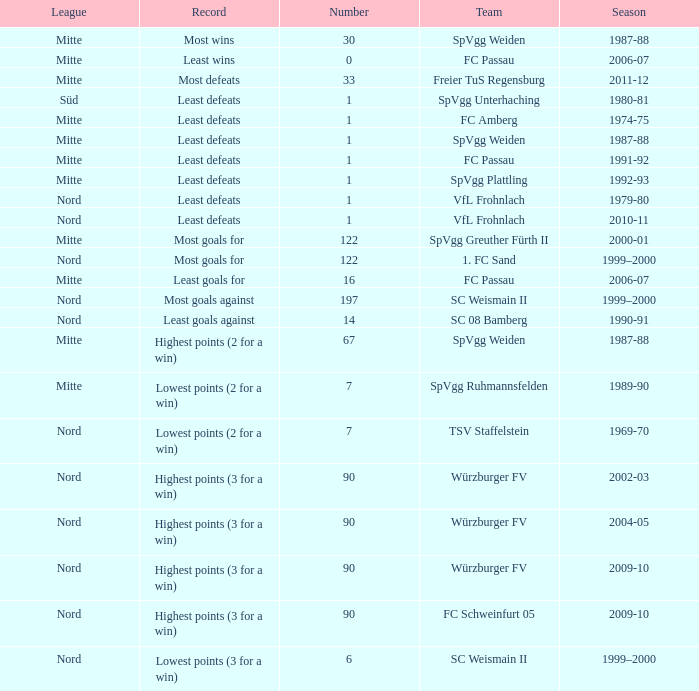Could you help me parse every detail presented in this table? {'header': ['League', 'Record', 'Number', 'Team', 'Season'], 'rows': [['Mitte', 'Most wins', '30', 'SpVgg Weiden', '1987-88'], ['Mitte', 'Least wins', '0', 'FC Passau', '2006-07'], ['Mitte', 'Most defeats', '33', 'Freier TuS Regensburg', '2011-12'], ['Süd', 'Least defeats', '1', 'SpVgg Unterhaching', '1980-81'], ['Mitte', 'Least defeats', '1', 'FC Amberg', '1974-75'], ['Mitte', 'Least defeats', '1', 'SpVgg Weiden', '1987-88'], ['Mitte', 'Least defeats', '1', 'FC Passau', '1991-92'], ['Mitte', 'Least defeats', '1', 'SpVgg Plattling', '1992-93'], ['Nord', 'Least defeats', '1', 'VfL Frohnlach', '1979-80'], ['Nord', 'Least defeats', '1', 'VfL Frohnlach', '2010-11'], ['Mitte', 'Most goals for', '122', 'SpVgg Greuther Fürth II', '2000-01'], ['Nord', 'Most goals for', '122', '1. FC Sand', '1999–2000'], ['Mitte', 'Least goals for', '16', 'FC Passau', '2006-07'], ['Nord', 'Most goals against', '197', 'SC Weismain II', '1999–2000'], ['Nord', 'Least goals against', '14', 'SC 08 Bamberg', '1990-91'], ['Mitte', 'Highest points (2 for a win)', '67', 'SpVgg Weiden', '1987-88'], ['Mitte', 'Lowest points (2 for a win)', '7', 'SpVgg Ruhmannsfelden', '1989-90'], ['Nord', 'Lowest points (2 for a win)', '7', 'TSV Staffelstein', '1969-70'], ['Nord', 'Highest points (3 for a win)', '90', 'Würzburger FV', '2002-03'], ['Nord', 'Highest points (3 for a win)', '90', 'Würzburger FV', '2004-05'], ['Nord', 'Highest points (3 for a win)', '90', 'Würzburger FV', '2009-10'], ['Nord', 'Highest points (3 for a win)', '90', 'FC Schweinfurt 05', '2009-10'], ['Nord', 'Lowest points (3 for a win)', '6', 'SC Weismain II', '1999–2000']]} What team has 2000-01 as the season? SpVgg Greuther Fürth II. 